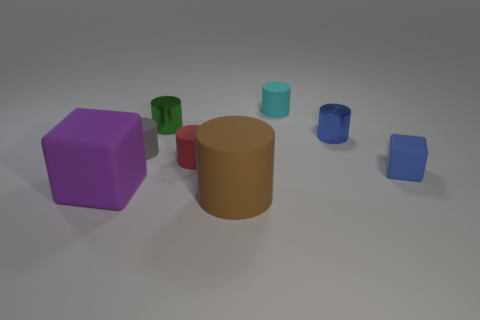Subtract all gray matte cylinders. How many cylinders are left? 5 Subtract 2 cylinders. How many cylinders are left? 4 Add 2 big green metallic cylinders. How many objects exist? 10 Subtract all cyan cylinders. How many cylinders are left? 5 Subtract all cylinders. How many objects are left? 2 Subtract all yellow cubes. Subtract all cyan cylinders. How many cubes are left? 2 Subtract all gray balls. How many green blocks are left? 0 Subtract all purple rubber objects. Subtract all purple matte things. How many objects are left? 6 Add 5 tiny blue metal cylinders. How many tiny blue metal cylinders are left? 6 Add 1 red matte objects. How many red matte objects exist? 2 